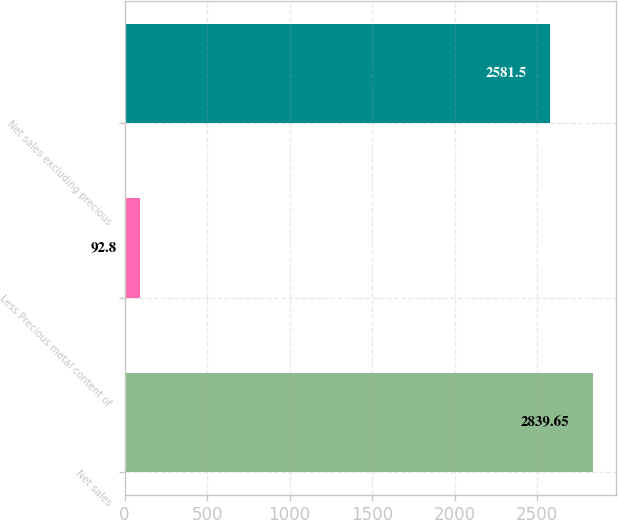<chart> <loc_0><loc_0><loc_500><loc_500><bar_chart><fcel>Net sales<fcel>Less Precious metal content of<fcel>Net sales excluding precious<nl><fcel>2839.65<fcel>92.8<fcel>2581.5<nl></chart> 